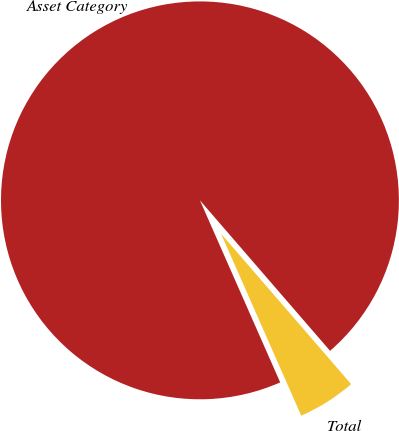<chart> <loc_0><loc_0><loc_500><loc_500><pie_chart><fcel>Asset Category<fcel>Total<nl><fcel>95.26%<fcel>4.74%<nl></chart> 